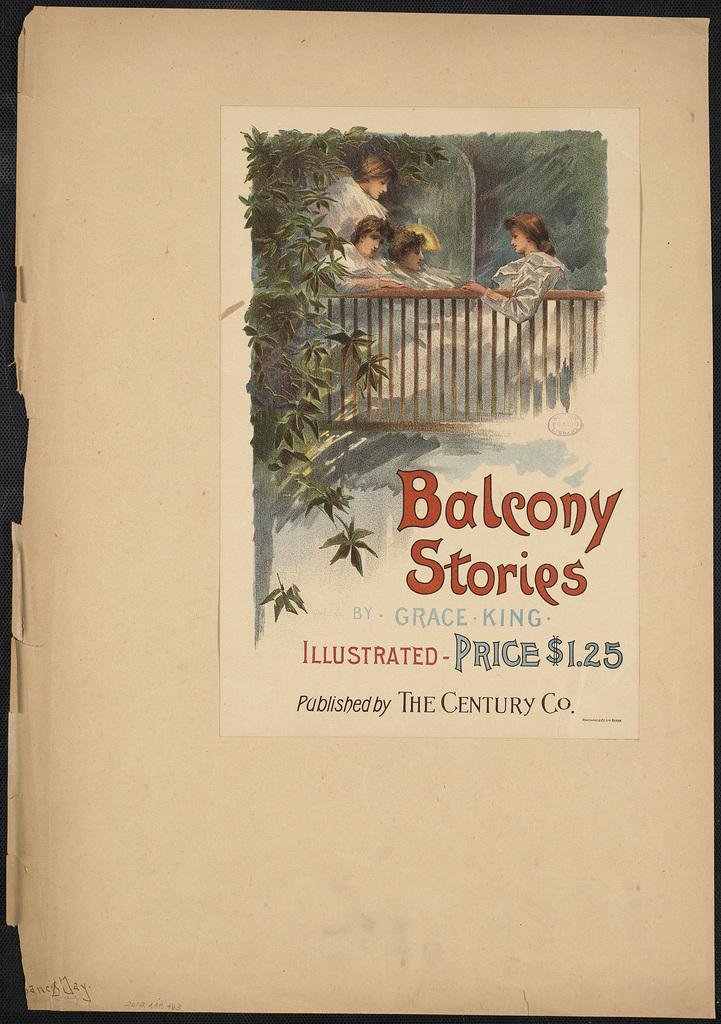Provide a one-sentence caption for the provided image. An antique book titled Balcony Stories by Grace King. 